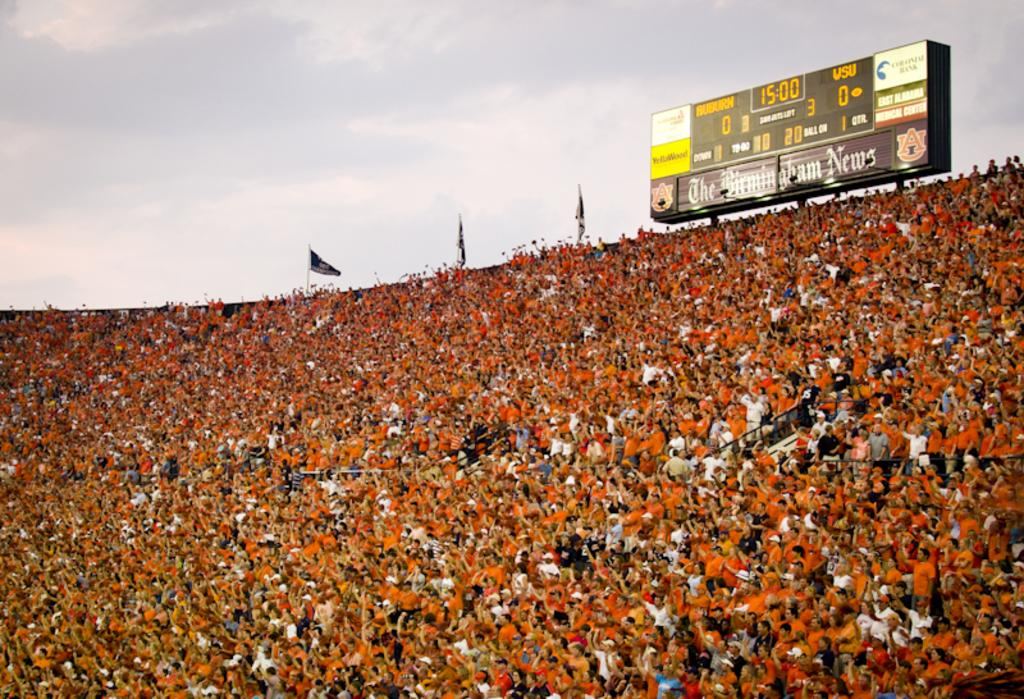<image>
Create a compact narrative representing the image presented. A very packed stadium shows a scoreboard with a tied game at 15:00. 